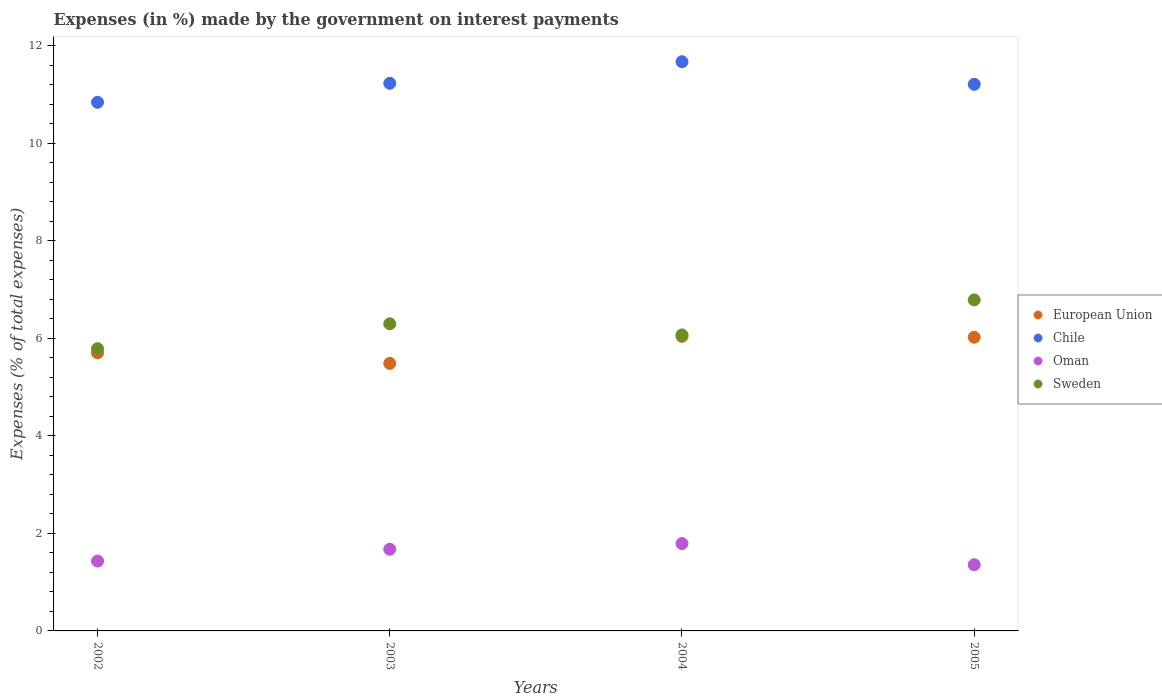How many different coloured dotlines are there?
Keep it short and to the point. 4. Is the number of dotlines equal to the number of legend labels?
Provide a succinct answer. Yes. What is the percentage of expenses made by the government on interest payments in Chile in 2005?
Offer a terse response. 11.21. Across all years, what is the maximum percentage of expenses made by the government on interest payments in Oman?
Keep it short and to the point. 1.79. Across all years, what is the minimum percentage of expenses made by the government on interest payments in Chile?
Provide a short and direct response. 10.84. What is the total percentage of expenses made by the government on interest payments in European Union in the graph?
Make the answer very short. 23.26. What is the difference between the percentage of expenses made by the government on interest payments in European Union in 2002 and that in 2004?
Offer a terse response. -0.34. What is the difference between the percentage of expenses made by the government on interest payments in Oman in 2003 and the percentage of expenses made by the government on interest payments in European Union in 2005?
Offer a very short reply. -4.35. What is the average percentage of expenses made by the government on interest payments in European Union per year?
Offer a terse response. 5.81. In the year 2005, what is the difference between the percentage of expenses made by the government on interest payments in Sweden and percentage of expenses made by the government on interest payments in Chile?
Offer a terse response. -4.42. In how many years, is the percentage of expenses made by the government on interest payments in European Union greater than 8.8 %?
Ensure brevity in your answer.  0. What is the ratio of the percentage of expenses made by the government on interest payments in Sweden in 2002 to that in 2004?
Make the answer very short. 0.95. Is the difference between the percentage of expenses made by the government on interest payments in Sweden in 2003 and 2005 greater than the difference between the percentage of expenses made by the government on interest payments in Chile in 2003 and 2005?
Your answer should be compact. No. What is the difference between the highest and the second highest percentage of expenses made by the government on interest payments in Chile?
Give a very brief answer. 0.44. What is the difference between the highest and the lowest percentage of expenses made by the government on interest payments in Chile?
Your answer should be very brief. 0.83. In how many years, is the percentage of expenses made by the government on interest payments in Chile greater than the average percentage of expenses made by the government on interest payments in Chile taken over all years?
Your answer should be compact. 1. Is it the case that in every year, the sum of the percentage of expenses made by the government on interest payments in Chile and percentage of expenses made by the government on interest payments in Sweden  is greater than the sum of percentage of expenses made by the government on interest payments in European Union and percentage of expenses made by the government on interest payments in Oman?
Your answer should be very brief. No. Does the percentage of expenses made by the government on interest payments in Sweden monotonically increase over the years?
Offer a terse response. No. Is the percentage of expenses made by the government on interest payments in Oman strictly less than the percentage of expenses made by the government on interest payments in Chile over the years?
Offer a very short reply. Yes. How many dotlines are there?
Offer a very short reply. 4. What is the difference between two consecutive major ticks on the Y-axis?
Make the answer very short. 2. Are the values on the major ticks of Y-axis written in scientific E-notation?
Ensure brevity in your answer.  No. Does the graph contain grids?
Your answer should be very brief. No. Where does the legend appear in the graph?
Ensure brevity in your answer.  Center right. How many legend labels are there?
Your answer should be compact. 4. How are the legend labels stacked?
Offer a terse response. Vertical. What is the title of the graph?
Make the answer very short. Expenses (in %) made by the government on interest payments. Does "Cambodia" appear as one of the legend labels in the graph?
Your response must be concise. No. What is the label or title of the X-axis?
Your answer should be very brief. Years. What is the label or title of the Y-axis?
Your answer should be very brief. Expenses (% of total expenses). What is the Expenses (% of total expenses) in European Union in 2002?
Ensure brevity in your answer.  5.7. What is the Expenses (% of total expenses) in Chile in 2002?
Your answer should be compact. 10.84. What is the Expenses (% of total expenses) of Oman in 2002?
Provide a succinct answer. 1.43. What is the Expenses (% of total expenses) of Sweden in 2002?
Keep it short and to the point. 5.79. What is the Expenses (% of total expenses) in European Union in 2003?
Make the answer very short. 5.49. What is the Expenses (% of total expenses) of Chile in 2003?
Offer a terse response. 11.23. What is the Expenses (% of total expenses) of Oman in 2003?
Your answer should be very brief. 1.67. What is the Expenses (% of total expenses) of Sweden in 2003?
Provide a succinct answer. 6.3. What is the Expenses (% of total expenses) in European Union in 2004?
Ensure brevity in your answer.  6.04. What is the Expenses (% of total expenses) of Chile in 2004?
Keep it short and to the point. 11.68. What is the Expenses (% of total expenses) of Oman in 2004?
Ensure brevity in your answer.  1.79. What is the Expenses (% of total expenses) of Sweden in 2004?
Make the answer very short. 6.07. What is the Expenses (% of total expenses) of European Union in 2005?
Your answer should be very brief. 6.02. What is the Expenses (% of total expenses) in Chile in 2005?
Provide a succinct answer. 11.21. What is the Expenses (% of total expenses) in Oman in 2005?
Provide a short and direct response. 1.36. What is the Expenses (% of total expenses) of Sweden in 2005?
Give a very brief answer. 6.79. Across all years, what is the maximum Expenses (% of total expenses) of European Union?
Give a very brief answer. 6.04. Across all years, what is the maximum Expenses (% of total expenses) of Chile?
Provide a succinct answer. 11.68. Across all years, what is the maximum Expenses (% of total expenses) in Oman?
Make the answer very short. 1.79. Across all years, what is the maximum Expenses (% of total expenses) in Sweden?
Your answer should be compact. 6.79. Across all years, what is the minimum Expenses (% of total expenses) in European Union?
Provide a short and direct response. 5.49. Across all years, what is the minimum Expenses (% of total expenses) of Chile?
Provide a short and direct response. 10.84. Across all years, what is the minimum Expenses (% of total expenses) in Oman?
Offer a very short reply. 1.36. Across all years, what is the minimum Expenses (% of total expenses) in Sweden?
Provide a succinct answer. 5.79. What is the total Expenses (% of total expenses) of European Union in the graph?
Your answer should be compact. 23.26. What is the total Expenses (% of total expenses) of Chile in the graph?
Provide a short and direct response. 44.97. What is the total Expenses (% of total expenses) in Oman in the graph?
Keep it short and to the point. 6.26. What is the total Expenses (% of total expenses) in Sweden in the graph?
Your answer should be very brief. 24.95. What is the difference between the Expenses (% of total expenses) in European Union in 2002 and that in 2003?
Your answer should be very brief. 0.22. What is the difference between the Expenses (% of total expenses) of Chile in 2002 and that in 2003?
Provide a short and direct response. -0.39. What is the difference between the Expenses (% of total expenses) in Oman in 2002 and that in 2003?
Provide a short and direct response. -0.24. What is the difference between the Expenses (% of total expenses) in Sweden in 2002 and that in 2003?
Your answer should be compact. -0.51. What is the difference between the Expenses (% of total expenses) of European Union in 2002 and that in 2004?
Provide a short and direct response. -0.34. What is the difference between the Expenses (% of total expenses) of Chile in 2002 and that in 2004?
Provide a succinct answer. -0.83. What is the difference between the Expenses (% of total expenses) in Oman in 2002 and that in 2004?
Your response must be concise. -0.36. What is the difference between the Expenses (% of total expenses) of Sweden in 2002 and that in 2004?
Your response must be concise. -0.28. What is the difference between the Expenses (% of total expenses) of European Union in 2002 and that in 2005?
Your answer should be very brief. -0.32. What is the difference between the Expenses (% of total expenses) in Chile in 2002 and that in 2005?
Ensure brevity in your answer.  -0.37. What is the difference between the Expenses (% of total expenses) in Oman in 2002 and that in 2005?
Offer a very short reply. 0.08. What is the difference between the Expenses (% of total expenses) of Sweden in 2002 and that in 2005?
Provide a short and direct response. -1. What is the difference between the Expenses (% of total expenses) in European Union in 2003 and that in 2004?
Provide a short and direct response. -0.55. What is the difference between the Expenses (% of total expenses) in Chile in 2003 and that in 2004?
Provide a short and direct response. -0.44. What is the difference between the Expenses (% of total expenses) of Oman in 2003 and that in 2004?
Provide a succinct answer. -0.12. What is the difference between the Expenses (% of total expenses) of Sweden in 2003 and that in 2004?
Ensure brevity in your answer.  0.23. What is the difference between the Expenses (% of total expenses) of European Union in 2003 and that in 2005?
Keep it short and to the point. -0.54. What is the difference between the Expenses (% of total expenses) of Chile in 2003 and that in 2005?
Your answer should be compact. 0.02. What is the difference between the Expenses (% of total expenses) in Oman in 2003 and that in 2005?
Provide a short and direct response. 0.32. What is the difference between the Expenses (% of total expenses) of Sweden in 2003 and that in 2005?
Your answer should be compact. -0.49. What is the difference between the Expenses (% of total expenses) of European Union in 2004 and that in 2005?
Offer a very short reply. 0.02. What is the difference between the Expenses (% of total expenses) in Chile in 2004 and that in 2005?
Offer a terse response. 0.46. What is the difference between the Expenses (% of total expenses) of Oman in 2004 and that in 2005?
Provide a short and direct response. 0.43. What is the difference between the Expenses (% of total expenses) in Sweden in 2004 and that in 2005?
Your answer should be compact. -0.72. What is the difference between the Expenses (% of total expenses) of European Union in 2002 and the Expenses (% of total expenses) of Chile in 2003?
Your answer should be very brief. -5.53. What is the difference between the Expenses (% of total expenses) of European Union in 2002 and the Expenses (% of total expenses) of Oman in 2003?
Offer a terse response. 4.03. What is the difference between the Expenses (% of total expenses) of European Union in 2002 and the Expenses (% of total expenses) of Sweden in 2003?
Your answer should be compact. -0.6. What is the difference between the Expenses (% of total expenses) of Chile in 2002 and the Expenses (% of total expenses) of Oman in 2003?
Your answer should be compact. 9.17. What is the difference between the Expenses (% of total expenses) of Chile in 2002 and the Expenses (% of total expenses) of Sweden in 2003?
Offer a terse response. 4.54. What is the difference between the Expenses (% of total expenses) in Oman in 2002 and the Expenses (% of total expenses) in Sweden in 2003?
Provide a succinct answer. -4.87. What is the difference between the Expenses (% of total expenses) of European Union in 2002 and the Expenses (% of total expenses) of Chile in 2004?
Your response must be concise. -5.97. What is the difference between the Expenses (% of total expenses) in European Union in 2002 and the Expenses (% of total expenses) in Oman in 2004?
Provide a succinct answer. 3.91. What is the difference between the Expenses (% of total expenses) in European Union in 2002 and the Expenses (% of total expenses) in Sweden in 2004?
Give a very brief answer. -0.37. What is the difference between the Expenses (% of total expenses) of Chile in 2002 and the Expenses (% of total expenses) of Oman in 2004?
Provide a succinct answer. 9.05. What is the difference between the Expenses (% of total expenses) of Chile in 2002 and the Expenses (% of total expenses) of Sweden in 2004?
Your answer should be very brief. 4.77. What is the difference between the Expenses (% of total expenses) in Oman in 2002 and the Expenses (% of total expenses) in Sweden in 2004?
Ensure brevity in your answer.  -4.64. What is the difference between the Expenses (% of total expenses) in European Union in 2002 and the Expenses (% of total expenses) in Chile in 2005?
Ensure brevity in your answer.  -5.51. What is the difference between the Expenses (% of total expenses) in European Union in 2002 and the Expenses (% of total expenses) in Oman in 2005?
Provide a succinct answer. 4.35. What is the difference between the Expenses (% of total expenses) of European Union in 2002 and the Expenses (% of total expenses) of Sweden in 2005?
Your response must be concise. -1.09. What is the difference between the Expenses (% of total expenses) of Chile in 2002 and the Expenses (% of total expenses) of Oman in 2005?
Your answer should be compact. 9.49. What is the difference between the Expenses (% of total expenses) in Chile in 2002 and the Expenses (% of total expenses) in Sweden in 2005?
Provide a short and direct response. 4.05. What is the difference between the Expenses (% of total expenses) in Oman in 2002 and the Expenses (% of total expenses) in Sweden in 2005?
Your response must be concise. -5.36. What is the difference between the Expenses (% of total expenses) in European Union in 2003 and the Expenses (% of total expenses) in Chile in 2004?
Your answer should be compact. -6.19. What is the difference between the Expenses (% of total expenses) of European Union in 2003 and the Expenses (% of total expenses) of Oman in 2004?
Make the answer very short. 3.7. What is the difference between the Expenses (% of total expenses) of European Union in 2003 and the Expenses (% of total expenses) of Sweden in 2004?
Give a very brief answer. -0.58. What is the difference between the Expenses (% of total expenses) of Chile in 2003 and the Expenses (% of total expenses) of Oman in 2004?
Make the answer very short. 9.44. What is the difference between the Expenses (% of total expenses) of Chile in 2003 and the Expenses (% of total expenses) of Sweden in 2004?
Provide a succinct answer. 5.16. What is the difference between the Expenses (% of total expenses) of Oman in 2003 and the Expenses (% of total expenses) of Sweden in 2004?
Keep it short and to the point. -4.4. What is the difference between the Expenses (% of total expenses) of European Union in 2003 and the Expenses (% of total expenses) of Chile in 2005?
Ensure brevity in your answer.  -5.72. What is the difference between the Expenses (% of total expenses) of European Union in 2003 and the Expenses (% of total expenses) of Oman in 2005?
Offer a terse response. 4.13. What is the difference between the Expenses (% of total expenses) in European Union in 2003 and the Expenses (% of total expenses) in Sweden in 2005?
Provide a short and direct response. -1.3. What is the difference between the Expenses (% of total expenses) of Chile in 2003 and the Expenses (% of total expenses) of Oman in 2005?
Offer a very short reply. 9.88. What is the difference between the Expenses (% of total expenses) in Chile in 2003 and the Expenses (% of total expenses) in Sweden in 2005?
Your answer should be compact. 4.44. What is the difference between the Expenses (% of total expenses) in Oman in 2003 and the Expenses (% of total expenses) in Sweden in 2005?
Keep it short and to the point. -5.12. What is the difference between the Expenses (% of total expenses) in European Union in 2004 and the Expenses (% of total expenses) in Chile in 2005?
Give a very brief answer. -5.17. What is the difference between the Expenses (% of total expenses) in European Union in 2004 and the Expenses (% of total expenses) in Oman in 2005?
Provide a short and direct response. 4.68. What is the difference between the Expenses (% of total expenses) of European Union in 2004 and the Expenses (% of total expenses) of Sweden in 2005?
Offer a very short reply. -0.75. What is the difference between the Expenses (% of total expenses) in Chile in 2004 and the Expenses (% of total expenses) in Oman in 2005?
Give a very brief answer. 10.32. What is the difference between the Expenses (% of total expenses) of Chile in 2004 and the Expenses (% of total expenses) of Sweden in 2005?
Make the answer very short. 4.89. What is the difference between the Expenses (% of total expenses) in Oman in 2004 and the Expenses (% of total expenses) in Sweden in 2005?
Ensure brevity in your answer.  -5. What is the average Expenses (% of total expenses) in European Union per year?
Offer a very short reply. 5.81. What is the average Expenses (% of total expenses) in Chile per year?
Make the answer very short. 11.24. What is the average Expenses (% of total expenses) in Oman per year?
Offer a very short reply. 1.56. What is the average Expenses (% of total expenses) in Sweden per year?
Provide a short and direct response. 6.24. In the year 2002, what is the difference between the Expenses (% of total expenses) of European Union and Expenses (% of total expenses) of Chile?
Your answer should be very brief. -5.14. In the year 2002, what is the difference between the Expenses (% of total expenses) in European Union and Expenses (% of total expenses) in Oman?
Provide a succinct answer. 4.27. In the year 2002, what is the difference between the Expenses (% of total expenses) in European Union and Expenses (% of total expenses) in Sweden?
Keep it short and to the point. -0.09. In the year 2002, what is the difference between the Expenses (% of total expenses) of Chile and Expenses (% of total expenses) of Oman?
Keep it short and to the point. 9.41. In the year 2002, what is the difference between the Expenses (% of total expenses) in Chile and Expenses (% of total expenses) in Sweden?
Offer a terse response. 5.05. In the year 2002, what is the difference between the Expenses (% of total expenses) in Oman and Expenses (% of total expenses) in Sweden?
Your response must be concise. -4.36. In the year 2003, what is the difference between the Expenses (% of total expenses) of European Union and Expenses (% of total expenses) of Chile?
Provide a short and direct response. -5.75. In the year 2003, what is the difference between the Expenses (% of total expenses) of European Union and Expenses (% of total expenses) of Oman?
Your response must be concise. 3.81. In the year 2003, what is the difference between the Expenses (% of total expenses) of European Union and Expenses (% of total expenses) of Sweden?
Your response must be concise. -0.81. In the year 2003, what is the difference between the Expenses (% of total expenses) of Chile and Expenses (% of total expenses) of Oman?
Keep it short and to the point. 9.56. In the year 2003, what is the difference between the Expenses (% of total expenses) in Chile and Expenses (% of total expenses) in Sweden?
Offer a very short reply. 4.93. In the year 2003, what is the difference between the Expenses (% of total expenses) in Oman and Expenses (% of total expenses) in Sweden?
Your response must be concise. -4.63. In the year 2004, what is the difference between the Expenses (% of total expenses) of European Union and Expenses (% of total expenses) of Chile?
Ensure brevity in your answer.  -5.63. In the year 2004, what is the difference between the Expenses (% of total expenses) of European Union and Expenses (% of total expenses) of Oman?
Provide a short and direct response. 4.25. In the year 2004, what is the difference between the Expenses (% of total expenses) in European Union and Expenses (% of total expenses) in Sweden?
Offer a terse response. -0.03. In the year 2004, what is the difference between the Expenses (% of total expenses) of Chile and Expenses (% of total expenses) of Oman?
Ensure brevity in your answer.  9.88. In the year 2004, what is the difference between the Expenses (% of total expenses) of Chile and Expenses (% of total expenses) of Sweden?
Provide a succinct answer. 5.6. In the year 2004, what is the difference between the Expenses (% of total expenses) in Oman and Expenses (% of total expenses) in Sweden?
Your answer should be very brief. -4.28. In the year 2005, what is the difference between the Expenses (% of total expenses) in European Union and Expenses (% of total expenses) in Chile?
Your answer should be compact. -5.19. In the year 2005, what is the difference between the Expenses (% of total expenses) of European Union and Expenses (% of total expenses) of Oman?
Keep it short and to the point. 4.67. In the year 2005, what is the difference between the Expenses (% of total expenses) of European Union and Expenses (% of total expenses) of Sweden?
Give a very brief answer. -0.77. In the year 2005, what is the difference between the Expenses (% of total expenses) in Chile and Expenses (% of total expenses) in Oman?
Keep it short and to the point. 9.85. In the year 2005, what is the difference between the Expenses (% of total expenses) in Chile and Expenses (% of total expenses) in Sweden?
Give a very brief answer. 4.42. In the year 2005, what is the difference between the Expenses (% of total expenses) in Oman and Expenses (% of total expenses) in Sweden?
Your response must be concise. -5.43. What is the ratio of the Expenses (% of total expenses) in European Union in 2002 to that in 2003?
Give a very brief answer. 1.04. What is the ratio of the Expenses (% of total expenses) in Chile in 2002 to that in 2003?
Your response must be concise. 0.97. What is the ratio of the Expenses (% of total expenses) in Oman in 2002 to that in 2003?
Provide a succinct answer. 0.86. What is the ratio of the Expenses (% of total expenses) in Sweden in 2002 to that in 2003?
Your answer should be compact. 0.92. What is the ratio of the Expenses (% of total expenses) of European Union in 2002 to that in 2004?
Offer a very short reply. 0.94. What is the ratio of the Expenses (% of total expenses) in Chile in 2002 to that in 2004?
Make the answer very short. 0.93. What is the ratio of the Expenses (% of total expenses) in Oman in 2002 to that in 2004?
Offer a terse response. 0.8. What is the ratio of the Expenses (% of total expenses) of Sweden in 2002 to that in 2004?
Offer a very short reply. 0.95. What is the ratio of the Expenses (% of total expenses) in European Union in 2002 to that in 2005?
Give a very brief answer. 0.95. What is the ratio of the Expenses (% of total expenses) in Chile in 2002 to that in 2005?
Offer a very short reply. 0.97. What is the ratio of the Expenses (% of total expenses) of Oman in 2002 to that in 2005?
Your answer should be compact. 1.06. What is the ratio of the Expenses (% of total expenses) of Sweden in 2002 to that in 2005?
Give a very brief answer. 0.85. What is the ratio of the Expenses (% of total expenses) of European Union in 2003 to that in 2004?
Ensure brevity in your answer.  0.91. What is the ratio of the Expenses (% of total expenses) of Chile in 2003 to that in 2004?
Your answer should be compact. 0.96. What is the ratio of the Expenses (% of total expenses) of Oman in 2003 to that in 2004?
Your answer should be compact. 0.93. What is the ratio of the Expenses (% of total expenses) of Sweden in 2003 to that in 2004?
Your response must be concise. 1.04. What is the ratio of the Expenses (% of total expenses) of European Union in 2003 to that in 2005?
Your answer should be compact. 0.91. What is the ratio of the Expenses (% of total expenses) in Chile in 2003 to that in 2005?
Provide a short and direct response. 1. What is the ratio of the Expenses (% of total expenses) in Oman in 2003 to that in 2005?
Your response must be concise. 1.23. What is the ratio of the Expenses (% of total expenses) of Sweden in 2003 to that in 2005?
Your response must be concise. 0.93. What is the ratio of the Expenses (% of total expenses) in Chile in 2004 to that in 2005?
Your response must be concise. 1.04. What is the ratio of the Expenses (% of total expenses) of Oman in 2004 to that in 2005?
Provide a succinct answer. 1.32. What is the ratio of the Expenses (% of total expenses) of Sweden in 2004 to that in 2005?
Your answer should be very brief. 0.89. What is the difference between the highest and the second highest Expenses (% of total expenses) of European Union?
Ensure brevity in your answer.  0.02. What is the difference between the highest and the second highest Expenses (% of total expenses) in Chile?
Offer a terse response. 0.44. What is the difference between the highest and the second highest Expenses (% of total expenses) of Oman?
Ensure brevity in your answer.  0.12. What is the difference between the highest and the second highest Expenses (% of total expenses) in Sweden?
Your answer should be compact. 0.49. What is the difference between the highest and the lowest Expenses (% of total expenses) of European Union?
Your response must be concise. 0.55. What is the difference between the highest and the lowest Expenses (% of total expenses) in Chile?
Ensure brevity in your answer.  0.83. What is the difference between the highest and the lowest Expenses (% of total expenses) in Oman?
Your answer should be compact. 0.43. What is the difference between the highest and the lowest Expenses (% of total expenses) in Sweden?
Provide a short and direct response. 1. 